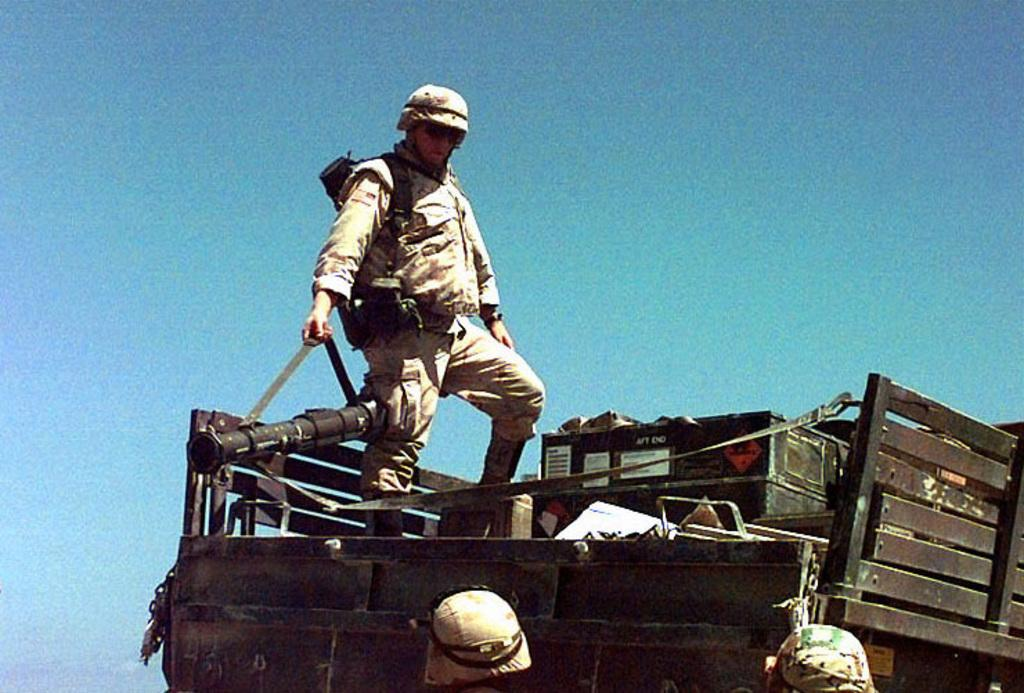What is the main subject of the image? There is a vehicle in the image. What is the person on the vehicle doing? A person is standing on the vehicle. What can be inferred about the person's occupation based on their attire? The person is wearing an army uniform, which suggests they might be a member of the military. How many people are standing near the vehicle? There are two people standing down from the vehicle. What type of insurance policy is being discussed by the committee in the image? There is no committee or discussion about insurance in the image; it features a vehicle with a person standing on it and two people standing nearby. 